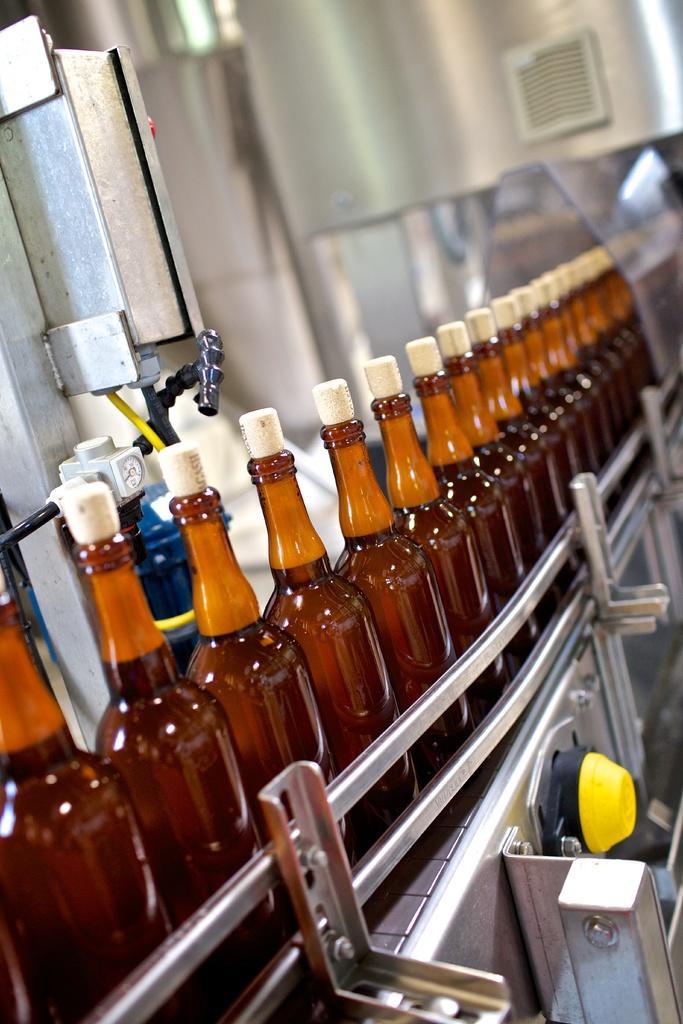Please provide a concise description of this image. In this image there are few bottles have cork on it. At the left side there is a metal. These bottles are on the machine. 